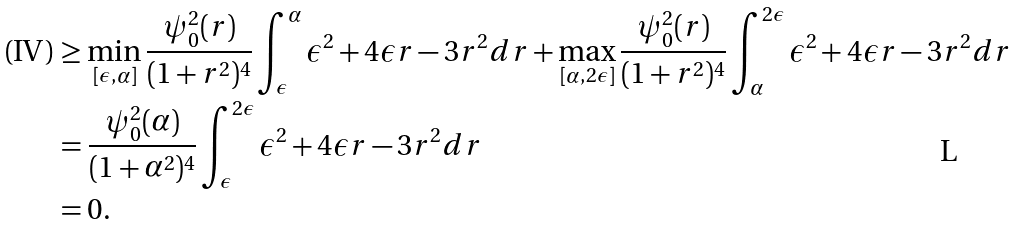Convert formula to latex. <formula><loc_0><loc_0><loc_500><loc_500>\text {(IV)} & \geq \min _ { [ \epsilon , \alpha ] } \frac { \psi _ { 0 } ^ { 2 } ( r ) } { ( 1 + r ^ { 2 } ) ^ { 4 } } \int _ { \epsilon } ^ { \alpha } \epsilon ^ { 2 } + 4 \epsilon r - 3 r ^ { 2 } d r + \max _ { [ \alpha , 2 \epsilon ] } \frac { \psi _ { 0 } ^ { 2 } ( r ) } { ( 1 + r ^ { 2 } ) ^ { 4 } } \int _ { \alpha } ^ { 2 \epsilon } \epsilon ^ { 2 } + 4 \epsilon r - 3 r ^ { 2 } d r \\ & = \frac { \psi _ { 0 } ^ { 2 } ( \alpha ) } { ( 1 + \alpha ^ { 2 } ) ^ { 4 } } \int _ { \epsilon } ^ { 2 \epsilon } \epsilon ^ { 2 } + 4 \epsilon r - 3 r ^ { 2 } d r \\ & = 0 . \\</formula> 